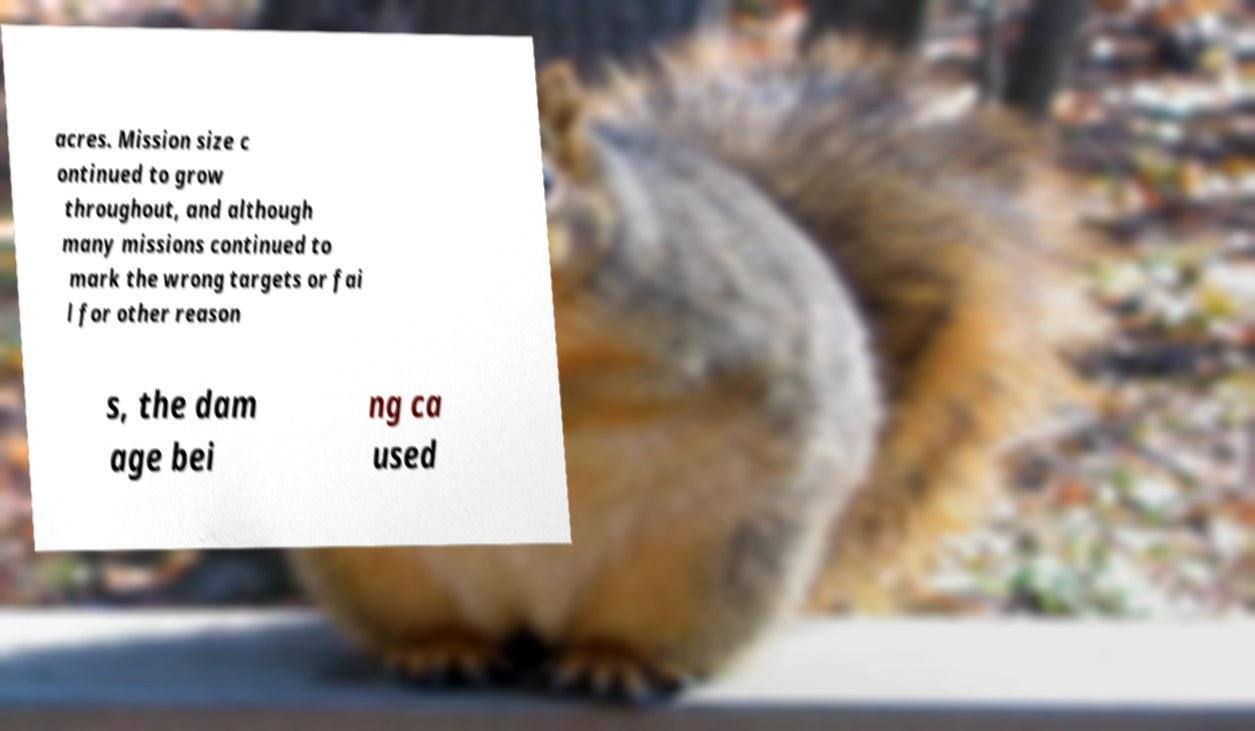For documentation purposes, I need the text within this image transcribed. Could you provide that? acres. Mission size c ontinued to grow throughout, and although many missions continued to mark the wrong targets or fai l for other reason s, the dam age bei ng ca used 